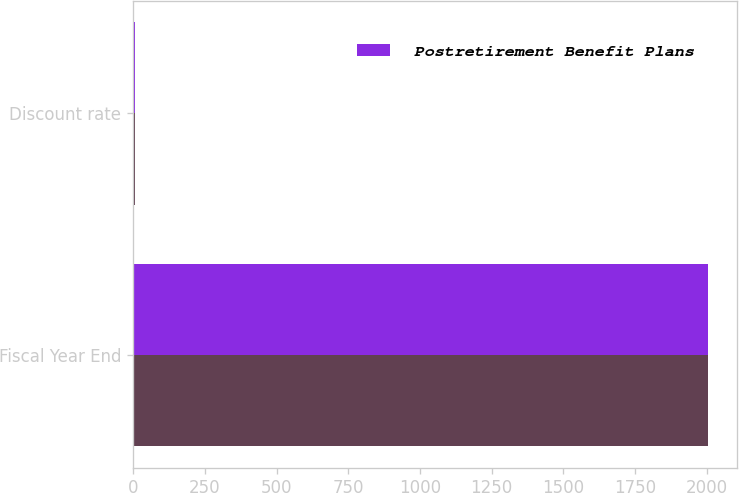<chart> <loc_0><loc_0><loc_500><loc_500><stacked_bar_chart><ecel><fcel>Fiscal Year End<fcel>Discount rate<nl><fcel>nan<fcel>2005<fcel>5.55<nl><fcel>Postretirement Benefit Plans<fcel>2005<fcel>5.5<nl></chart> 